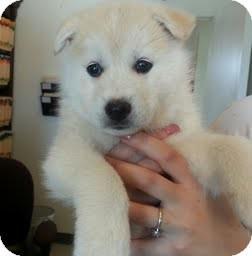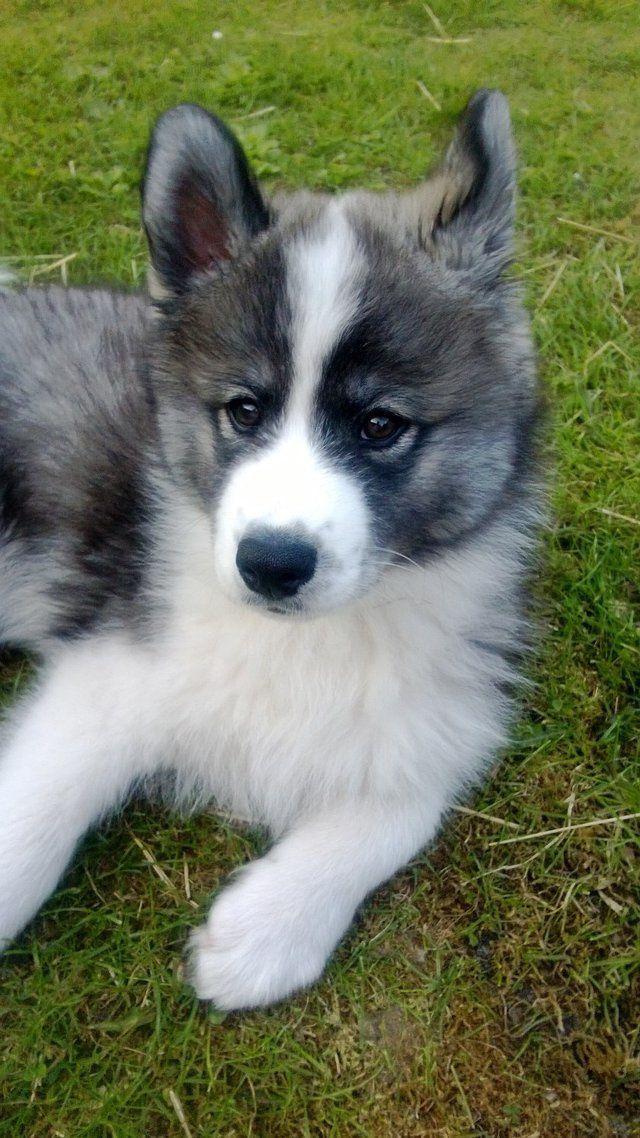The first image is the image on the left, the second image is the image on the right. Assess this claim about the two images: "One image shows exactly one white dog with its ears flopped forward, and the other image shows one dog with 'salt-and-pepper' fur coloring, and all dogs shown are young instead of full grown.". Correct or not? Answer yes or no. Yes. The first image is the image on the left, the second image is the image on the right. Given the left and right images, does the statement "A dog is looking toward the right side." hold true? Answer yes or no. No. 